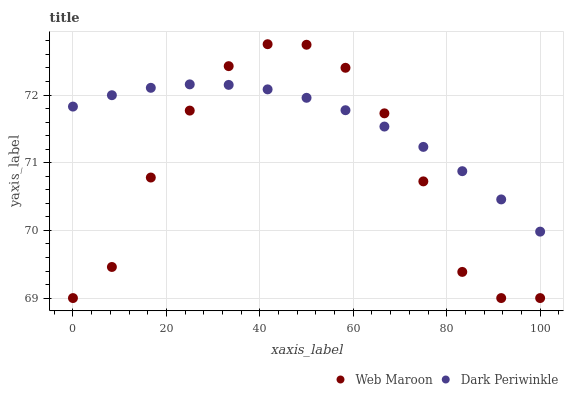Does Web Maroon have the minimum area under the curve?
Answer yes or no. Yes. Does Dark Periwinkle have the maximum area under the curve?
Answer yes or no. Yes. Does Dark Periwinkle have the minimum area under the curve?
Answer yes or no. No. Is Dark Periwinkle the smoothest?
Answer yes or no. Yes. Is Web Maroon the roughest?
Answer yes or no. Yes. Is Dark Periwinkle the roughest?
Answer yes or no. No. Does Web Maroon have the lowest value?
Answer yes or no. Yes. Does Dark Periwinkle have the lowest value?
Answer yes or no. No. Does Web Maroon have the highest value?
Answer yes or no. Yes. Does Dark Periwinkle have the highest value?
Answer yes or no. No. Does Dark Periwinkle intersect Web Maroon?
Answer yes or no. Yes. Is Dark Periwinkle less than Web Maroon?
Answer yes or no. No. Is Dark Periwinkle greater than Web Maroon?
Answer yes or no. No. 